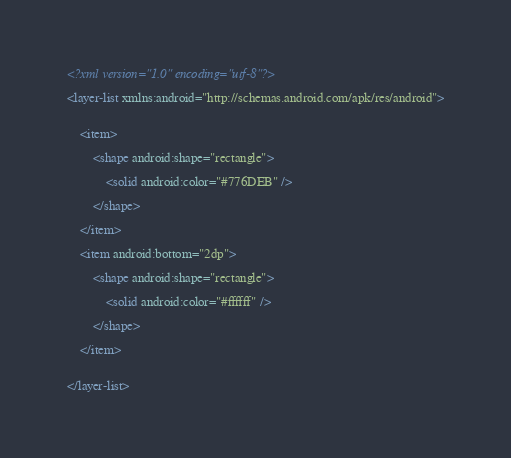<code> <loc_0><loc_0><loc_500><loc_500><_XML_><?xml version="1.0" encoding="utf-8"?>

<layer-list xmlns:android="http://schemas.android.com/apk/res/android">


    <item>

        <shape android:shape="rectangle">

            <solid android:color="#776DEB" />

        </shape>

    </item>

    <item android:bottom="2dp">

        <shape android:shape="rectangle">

            <solid android:color="#ffffff" />

        </shape>

    </item>


</layer-list>
</code> 